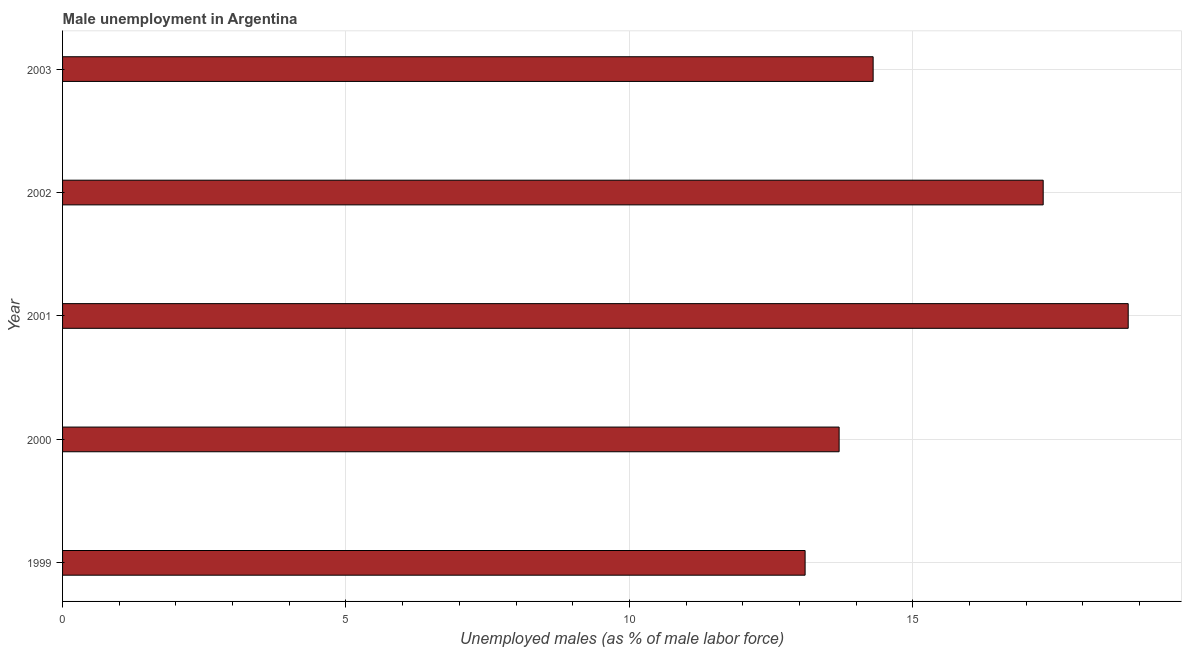What is the title of the graph?
Make the answer very short. Male unemployment in Argentina. What is the label or title of the X-axis?
Your response must be concise. Unemployed males (as % of male labor force). What is the label or title of the Y-axis?
Your answer should be compact. Year. What is the unemployed males population in 2003?
Provide a succinct answer. 14.3. Across all years, what is the maximum unemployed males population?
Give a very brief answer. 18.8. Across all years, what is the minimum unemployed males population?
Your answer should be compact. 13.1. In which year was the unemployed males population maximum?
Keep it short and to the point. 2001. In which year was the unemployed males population minimum?
Offer a terse response. 1999. What is the sum of the unemployed males population?
Ensure brevity in your answer.  77.2. What is the average unemployed males population per year?
Ensure brevity in your answer.  15.44. What is the median unemployed males population?
Offer a terse response. 14.3. In how many years, is the unemployed males population greater than 4 %?
Your answer should be compact. 5. What is the ratio of the unemployed males population in 2000 to that in 2001?
Give a very brief answer. 0.73. Is the sum of the unemployed males population in 1999 and 2003 greater than the maximum unemployed males population across all years?
Your response must be concise. Yes. Are all the bars in the graph horizontal?
Keep it short and to the point. Yes. How many years are there in the graph?
Provide a succinct answer. 5. What is the difference between two consecutive major ticks on the X-axis?
Provide a succinct answer. 5. Are the values on the major ticks of X-axis written in scientific E-notation?
Your answer should be very brief. No. What is the Unemployed males (as % of male labor force) of 1999?
Keep it short and to the point. 13.1. What is the Unemployed males (as % of male labor force) of 2000?
Offer a terse response. 13.7. What is the Unemployed males (as % of male labor force) of 2001?
Give a very brief answer. 18.8. What is the Unemployed males (as % of male labor force) in 2002?
Give a very brief answer. 17.3. What is the Unemployed males (as % of male labor force) of 2003?
Offer a terse response. 14.3. What is the difference between the Unemployed males (as % of male labor force) in 1999 and 2001?
Your answer should be very brief. -5.7. What is the difference between the Unemployed males (as % of male labor force) in 1999 and 2002?
Offer a very short reply. -4.2. What is the difference between the Unemployed males (as % of male labor force) in 1999 and 2003?
Ensure brevity in your answer.  -1.2. What is the difference between the Unemployed males (as % of male labor force) in 2000 and 2001?
Ensure brevity in your answer.  -5.1. What is the difference between the Unemployed males (as % of male labor force) in 2000 and 2002?
Keep it short and to the point. -3.6. What is the difference between the Unemployed males (as % of male labor force) in 2000 and 2003?
Offer a terse response. -0.6. What is the difference between the Unemployed males (as % of male labor force) in 2001 and 2003?
Your answer should be compact. 4.5. What is the difference between the Unemployed males (as % of male labor force) in 2002 and 2003?
Your response must be concise. 3. What is the ratio of the Unemployed males (as % of male labor force) in 1999 to that in 2000?
Your answer should be compact. 0.96. What is the ratio of the Unemployed males (as % of male labor force) in 1999 to that in 2001?
Offer a terse response. 0.7. What is the ratio of the Unemployed males (as % of male labor force) in 1999 to that in 2002?
Keep it short and to the point. 0.76. What is the ratio of the Unemployed males (as % of male labor force) in 1999 to that in 2003?
Offer a very short reply. 0.92. What is the ratio of the Unemployed males (as % of male labor force) in 2000 to that in 2001?
Your answer should be compact. 0.73. What is the ratio of the Unemployed males (as % of male labor force) in 2000 to that in 2002?
Your response must be concise. 0.79. What is the ratio of the Unemployed males (as % of male labor force) in 2000 to that in 2003?
Make the answer very short. 0.96. What is the ratio of the Unemployed males (as % of male labor force) in 2001 to that in 2002?
Keep it short and to the point. 1.09. What is the ratio of the Unemployed males (as % of male labor force) in 2001 to that in 2003?
Give a very brief answer. 1.31. What is the ratio of the Unemployed males (as % of male labor force) in 2002 to that in 2003?
Your answer should be compact. 1.21. 